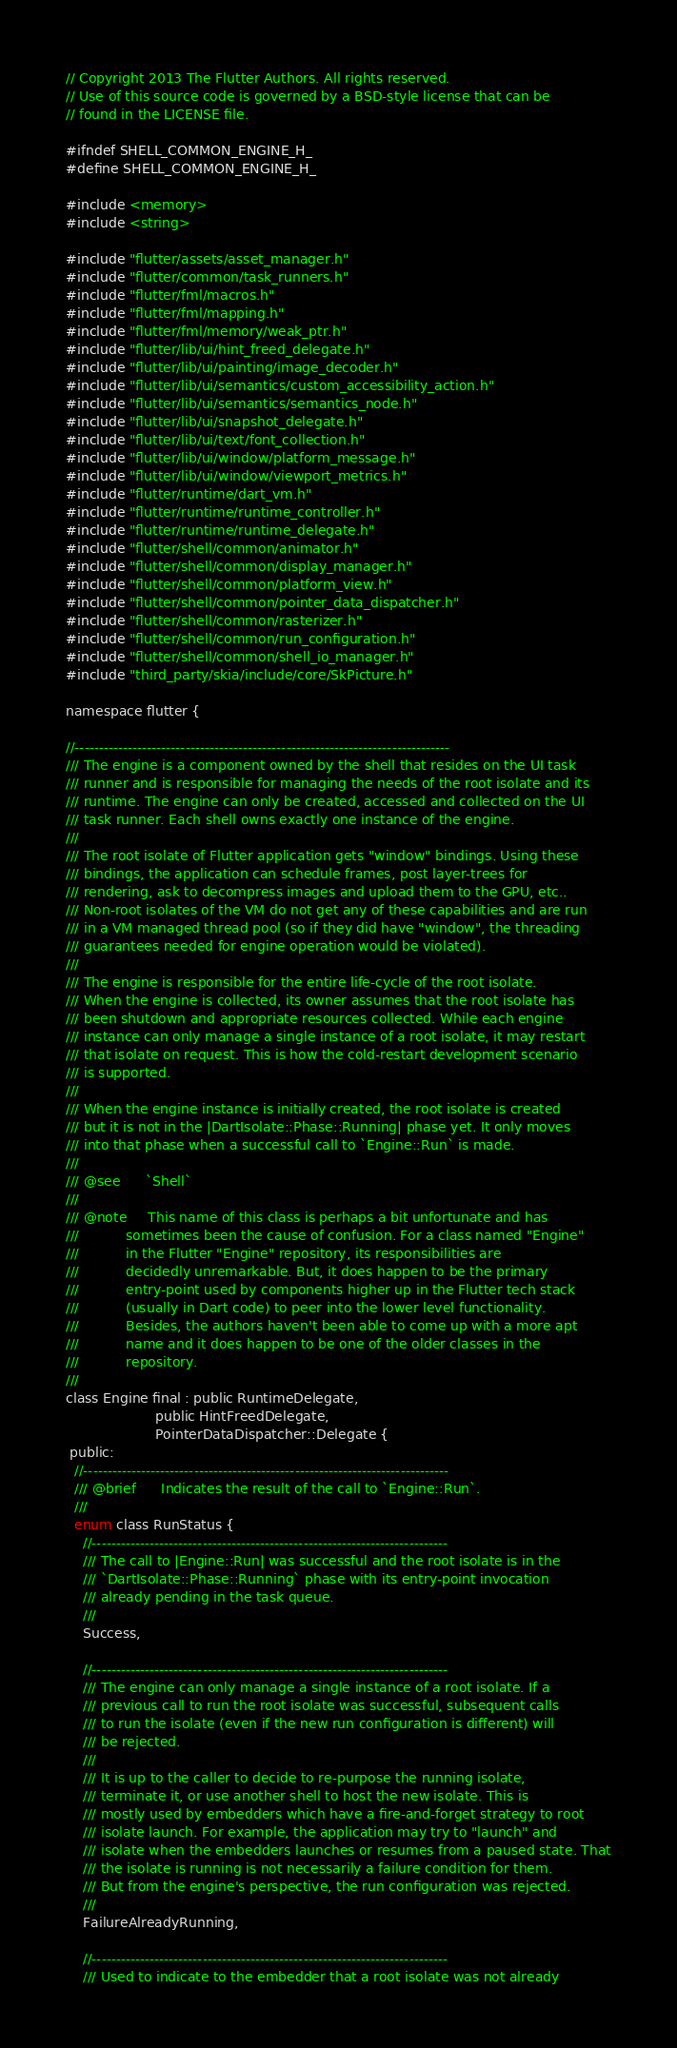Convert code to text. <code><loc_0><loc_0><loc_500><loc_500><_C_>// Copyright 2013 The Flutter Authors. All rights reserved.
// Use of this source code is governed by a BSD-style license that can be
// found in the LICENSE file.

#ifndef SHELL_COMMON_ENGINE_H_
#define SHELL_COMMON_ENGINE_H_

#include <memory>
#include <string>

#include "flutter/assets/asset_manager.h"
#include "flutter/common/task_runners.h"
#include "flutter/fml/macros.h"
#include "flutter/fml/mapping.h"
#include "flutter/fml/memory/weak_ptr.h"
#include "flutter/lib/ui/hint_freed_delegate.h"
#include "flutter/lib/ui/painting/image_decoder.h"
#include "flutter/lib/ui/semantics/custom_accessibility_action.h"
#include "flutter/lib/ui/semantics/semantics_node.h"
#include "flutter/lib/ui/snapshot_delegate.h"
#include "flutter/lib/ui/text/font_collection.h"
#include "flutter/lib/ui/window/platform_message.h"
#include "flutter/lib/ui/window/viewport_metrics.h"
#include "flutter/runtime/dart_vm.h"
#include "flutter/runtime/runtime_controller.h"
#include "flutter/runtime/runtime_delegate.h"
#include "flutter/shell/common/animator.h"
#include "flutter/shell/common/display_manager.h"
#include "flutter/shell/common/platform_view.h"
#include "flutter/shell/common/pointer_data_dispatcher.h"
#include "flutter/shell/common/rasterizer.h"
#include "flutter/shell/common/run_configuration.h"
#include "flutter/shell/common/shell_io_manager.h"
#include "third_party/skia/include/core/SkPicture.h"

namespace flutter {

//------------------------------------------------------------------------------
/// The engine is a component owned by the shell that resides on the UI task
/// runner and is responsible for managing the needs of the root isolate and its
/// runtime. The engine can only be created, accessed and collected on the UI
/// task runner. Each shell owns exactly one instance of the engine.
///
/// The root isolate of Flutter application gets "window" bindings. Using these
/// bindings, the application can schedule frames, post layer-trees for
/// rendering, ask to decompress images and upload them to the GPU, etc..
/// Non-root isolates of the VM do not get any of these capabilities and are run
/// in a VM managed thread pool (so if they did have "window", the threading
/// guarantees needed for engine operation would be violated).
///
/// The engine is responsible for the entire life-cycle of the root isolate.
/// When the engine is collected, its owner assumes that the root isolate has
/// been shutdown and appropriate resources collected. While each engine
/// instance can only manage a single instance of a root isolate, it may restart
/// that isolate on request. This is how the cold-restart development scenario
/// is supported.
///
/// When the engine instance is initially created, the root isolate is created
/// but it is not in the |DartIsolate::Phase::Running| phase yet. It only moves
/// into that phase when a successful call to `Engine::Run` is made.
///
/// @see      `Shell`
///
/// @note     This name of this class is perhaps a bit unfortunate and has
///           sometimes been the cause of confusion. For a class named "Engine"
///           in the Flutter "Engine" repository, its responsibilities are
///           decidedly unremarkable. But, it does happen to be the primary
///           entry-point used by components higher up in the Flutter tech stack
///           (usually in Dart code) to peer into the lower level functionality.
///           Besides, the authors haven't been able to come up with a more apt
///           name and it does happen to be one of the older classes in the
///           repository.
///
class Engine final : public RuntimeDelegate,
                     public HintFreedDelegate,
                     PointerDataDispatcher::Delegate {
 public:
  //----------------------------------------------------------------------------
  /// @brief      Indicates the result of the call to `Engine::Run`.
  ///
  enum class RunStatus {
    //--------------------------------------------------------------------------
    /// The call to |Engine::Run| was successful and the root isolate is in the
    /// `DartIsolate::Phase::Running` phase with its entry-point invocation
    /// already pending in the task queue.
    ///
    Success,

    //--------------------------------------------------------------------------
    /// The engine can only manage a single instance of a root isolate. If a
    /// previous call to run the root isolate was successful, subsequent calls
    /// to run the isolate (even if the new run configuration is different) will
    /// be rejected.
    ///
    /// It is up to the caller to decide to re-purpose the running isolate,
    /// terminate it, or use another shell to host the new isolate. This is
    /// mostly used by embedders which have a fire-and-forget strategy to root
    /// isolate launch. For example, the application may try to "launch" and
    /// isolate when the embedders launches or resumes from a paused state. That
    /// the isolate is running is not necessarily a failure condition for them.
    /// But from the engine's perspective, the run configuration was rejected.
    ///
    FailureAlreadyRunning,

    //--------------------------------------------------------------------------
    /// Used to indicate to the embedder that a root isolate was not already</code> 